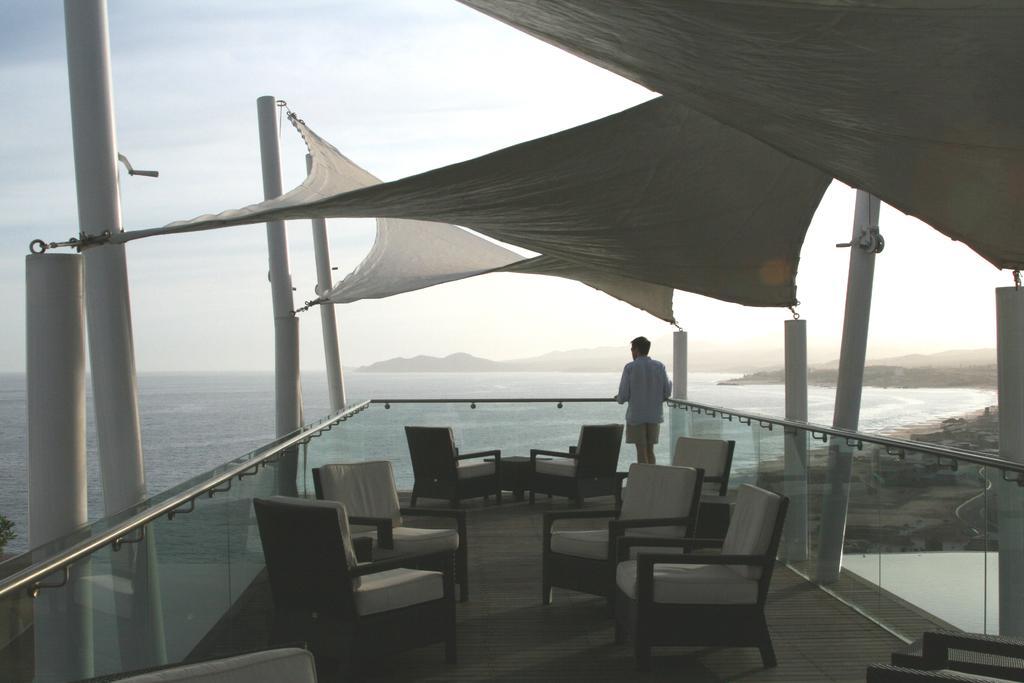Please provide a concise description of this image. In this image I can see a boat visible on lake , in the boat I can see chairs and a person standing in front of the fence of the boat , in the background I can see the sky. 